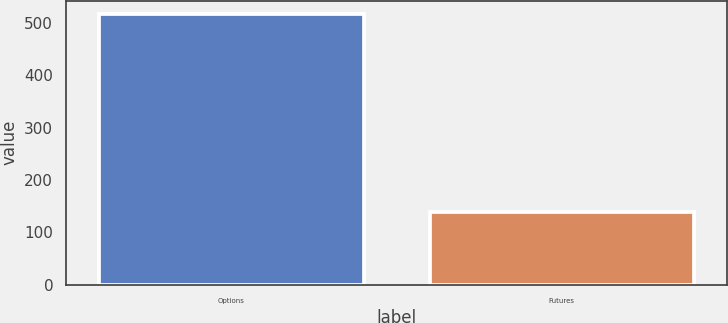<chart> <loc_0><loc_0><loc_500><loc_500><bar_chart><fcel>Options<fcel>Futures<nl><fcel>516.3<fcel>139.5<nl></chart> 